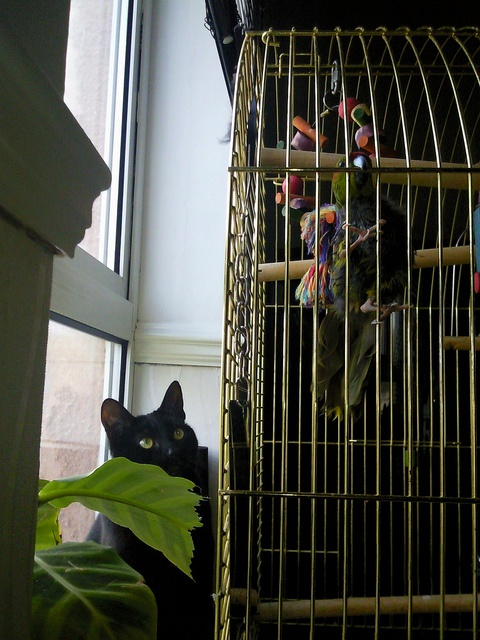Describe the objects in this image and their specific colors. I can see potted plant in black and darkgreen tones, bird in black, darkgreen, gray, and maroon tones, and cat in black, gray, and darkgreen tones in this image. 